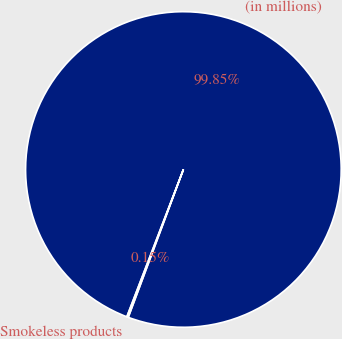<chart> <loc_0><loc_0><loc_500><loc_500><pie_chart><fcel>(in millions)<fcel>Smokeless products<nl><fcel>99.85%<fcel>0.15%<nl></chart> 